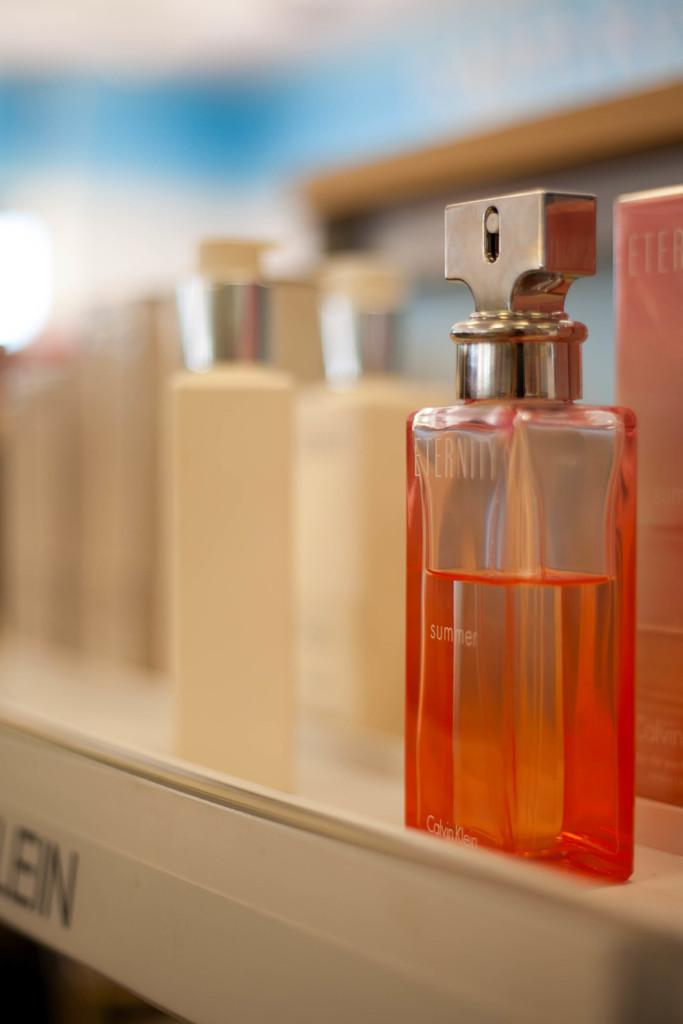Provide a one-sentence caption for the provided image. eternity perfum sits on a rack it looks half used. 